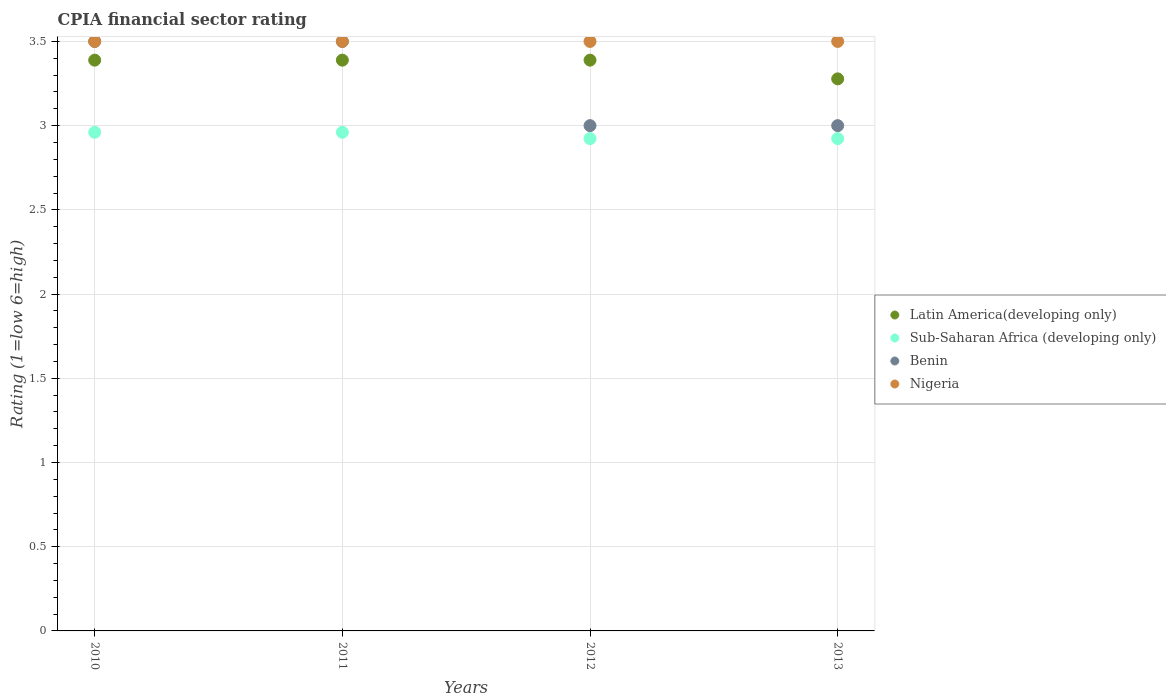Is the number of dotlines equal to the number of legend labels?
Provide a succinct answer. Yes. What is the CPIA rating in Sub-Saharan Africa (developing only) in 2013?
Provide a short and direct response. 2.92. Across all years, what is the maximum CPIA rating in Sub-Saharan Africa (developing only)?
Keep it short and to the point. 2.96. Across all years, what is the minimum CPIA rating in Latin America(developing only)?
Your answer should be very brief. 3.28. In which year was the CPIA rating in Sub-Saharan Africa (developing only) maximum?
Ensure brevity in your answer.  2010. What is the total CPIA rating in Nigeria in the graph?
Provide a short and direct response. 14. What is the difference between the CPIA rating in Latin America(developing only) in 2010 and that in 2013?
Your answer should be very brief. 0.11. What is the difference between the CPIA rating in Nigeria in 2010 and the CPIA rating in Latin America(developing only) in 2012?
Offer a very short reply. 0.11. What is the average CPIA rating in Benin per year?
Your answer should be very brief. 3.25. In the year 2012, what is the difference between the CPIA rating in Sub-Saharan Africa (developing only) and CPIA rating in Latin America(developing only)?
Make the answer very short. -0.47. In how many years, is the CPIA rating in Sub-Saharan Africa (developing only) greater than 1.9?
Keep it short and to the point. 4. What is the ratio of the CPIA rating in Benin in 2011 to that in 2013?
Your answer should be very brief. 1.17. What is the difference between the highest and the second highest CPIA rating in Sub-Saharan Africa (developing only)?
Offer a terse response. 0. What is the difference between the highest and the lowest CPIA rating in Sub-Saharan Africa (developing only)?
Keep it short and to the point. 0.04. In how many years, is the CPIA rating in Sub-Saharan Africa (developing only) greater than the average CPIA rating in Sub-Saharan Africa (developing only) taken over all years?
Ensure brevity in your answer.  2. Is it the case that in every year, the sum of the CPIA rating in Nigeria and CPIA rating in Sub-Saharan Africa (developing only)  is greater than the sum of CPIA rating in Latin America(developing only) and CPIA rating in Benin?
Your answer should be compact. No. Is the CPIA rating in Nigeria strictly greater than the CPIA rating in Latin America(developing only) over the years?
Provide a succinct answer. Yes. Is the CPIA rating in Nigeria strictly less than the CPIA rating in Benin over the years?
Keep it short and to the point. No. Does the graph contain any zero values?
Your answer should be compact. No. Where does the legend appear in the graph?
Your answer should be very brief. Center right. How many legend labels are there?
Your response must be concise. 4. How are the legend labels stacked?
Your answer should be very brief. Vertical. What is the title of the graph?
Ensure brevity in your answer.  CPIA financial sector rating. What is the label or title of the X-axis?
Your response must be concise. Years. What is the label or title of the Y-axis?
Offer a terse response. Rating (1=low 6=high). What is the Rating (1=low 6=high) in Latin America(developing only) in 2010?
Give a very brief answer. 3.39. What is the Rating (1=low 6=high) in Sub-Saharan Africa (developing only) in 2010?
Provide a succinct answer. 2.96. What is the Rating (1=low 6=high) of Nigeria in 2010?
Keep it short and to the point. 3.5. What is the Rating (1=low 6=high) of Latin America(developing only) in 2011?
Provide a succinct answer. 3.39. What is the Rating (1=low 6=high) of Sub-Saharan Africa (developing only) in 2011?
Make the answer very short. 2.96. What is the Rating (1=low 6=high) in Benin in 2011?
Provide a succinct answer. 3.5. What is the Rating (1=low 6=high) of Nigeria in 2011?
Provide a succinct answer. 3.5. What is the Rating (1=low 6=high) in Latin America(developing only) in 2012?
Your answer should be compact. 3.39. What is the Rating (1=low 6=high) in Sub-Saharan Africa (developing only) in 2012?
Your answer should be compact. 2.92. What is the Rating (1=low 6=high) of Latin America(developing only) in 2013?
Give a very brief answer. 3.28. What is the Rating (1=low 6=high) of Sub-Saharan Africa (developing only) in 2013?
Provide a short and direct response. 2.92. What is the Rating (1=low 6=high) of Nigeria in 2013?
Keep it short and to the point. 3.5. Across all years, what is the maximum Rating (1=low 6=high) in Latin America(developing only)?
Make the answer very short. 3.39. Across all years, what is the maximum Rating (1=low 6=high) of Sub-Saharan Africa (developing only)?
Your answer should be very brief. 2.96. Across all years, what is the maximum Rating (1=low 6=high) of Nigeria?
Keep it short and to the point. 3.5. Across all years, what is the minimum Rating (1=low 6=high) of Latin America(developing only)?
Offer a very short reply. 3.28. Across all years, what is the minimum Rating (1=low 6=high) in Sub-Saharan Africa (developing only)?
Provide a succinct answer. 2.92. Across all years, what is the minimum Rating (1=low 6=high) in Nigeria?
Your response must be concise. 3.5. What is the total Rating (1=low 6=high) of Latin America(developing only) in the graph?
Offer a terse response. 13.44. What is the total Rating (1=low 6=high) in Sub-Saharan Africa (developing only) in the graph?
Offer a terse response. 11.77. What is the total Rating (1=low 6=high) in Nigeria in the graph?
Offer a very short reply. 14. What is the difference between the Rating (1=low 6=high) in Benin in 2010 and that in 2011?
Your answer should be very brief. 0. What is the difference between the Rating (1=low 6=high) of Latin America(developing only) in 2010 and that in 2012?
Ensure brevity in your answer.  0. What is the difference between the Rating (1=low 6=high) of Sub-Saharan Africa (developing only) in 2010 and that in 2012?
Make the answer very short. 0.04. What is the difference between the Rating (1=low 6=high) in Benin in 2010 and that in 2012?
Your answer should be compact. 0.5. What is the difference between the Rating (1=low 6=high) in Sub-Saharan Africa (developing only) in 2010 and that in 2013?
Provide a short and direct response. 0.04. What is the difference between the Rating (1=low 6=high) in Benin in 2010 and that in 2013?
Offer a terse response. 0.5. What is the difference between the Rating (1=low 6=high) of Latin America(developing only) in 2011 and that in 2012?
Ensure brevity in your answer.  0. What is the difference between the Rating (1=low 6=high) in Sub-Saharan Africa (developing only) in 2011 and that in 2012?
Keep it short and to the point. 0.04. What is the difference between the Rating (1=low 6=high) in Nigeria in 2011 and that in 2012?
Keep it short and to the point. 0. What is the difference between the Rating (1=low 6=high) in Latin America(developing only) in 2011 and that in 2013?
Provide a short and direct response. 0.11. What is the difference between the Rating (1=low 6=high) in Sub-Saharan Africa (developing only) in 2011 and that in 2013?
Your answer should be compact. 0.04. What is the difference between the Rating (1=low 6=high) of Sub-Saharan Africa (developing only) in 2012 and that in 2013?
Ensure brevity in your answer.  0. What is the difference between the Rating (1=low 6=high) of Benin in 2012 and that in 2013?
Make the answer very short. 0. What is the difference between the Rating (1=low 6=high) in Nigeria in 2012 and that in 2013?
Offer a terse response. 0. What is the difference between the Rating (1=low 6=high) of Latin America(developing only) in 2010 and the Rating (1=low 6=high) of Sub-Saharan Africa (developing only) in 2011?
Your answer should be very brief. 0.43. What is the difference between the Rating (1=low 6=high) of Latin America(developing only) in 2010 and the Rating (1=low 6=high) of Benin in 2011?
Your answer should be very brief. -0.11. What is the difference between the Rating (1=low 6=high) of Latin America(developing only) in 2010 and the Rating (1=low 6=high) of Nigeria in 2011?
Make the answer very short. -0.11. What is the difference between the Rating (1=low 6=high) in Sub-Saharan Africa (developing only) in 2010 and the Rating (1=low 6=high) in Benin in 2011?
Offer a terse response. -0.54. What is the difference between the Rating (1=low 6=high) in Sub-Saharan Africa (developing only) in 2010 and the Rating (1=low 6=high) in Nigeria in 2011?
Offer a terse response. -0.54. What is the difference between the Rating (1=low 6=high) in Benin in 2010 and the Rating (1=low 6=high) in Nigeria in 2011?
Your response must be concise. 0. What is the difference between the Rating (1=low 6=high) of Latin America(developing only) in 2010 and the Rating (1=low 6=high) of Sub-Saharan Africa (developing only) in 2012?
Make the answer very short. 0.47. What is the difference between the Rating (1=low 6=high) of Latin America(developing only) in 2010 and the Rating (1=low 6=high) of Benin in 2012?
Ensure brevity in your answer.  0.39. What is the difference between the Rating (1=low 6=high) in Latin America(developing only) in 2010 and the Rating (1=low 6=high) in Nigeria in 2012?
Offer a terse response. -0.11. What is the difference between the Rating (1=low 6=high) of Sub-Saharan Africa (developing only) in 2010 and the Rating (1=low 6=high) of Benin in 2012?
Make the answer very short. -0.04. What is the difference between the Rating (1=low 6=high) in Sub-Saharan Africa (developing only) in 2010 and the Rating (1=low 6=high) in Nigeria in 2012?
Your response must be concise. -0.54. What is the difference between the Rating (1=low 6=high) of Latin America(developing only) in 2010 and the Rating (1=low 6=high) of Sub-Saharan Africa (developing only) in 2013?
Provide a short and direct response. 0.47. What is the difference between the Rating (1=low 6=high) in Latin America(developing only) in 2010 and the Rating (1=low 6=high) in Benin in 2013?
Offer a very short reply. 0.39. What is the difference between the Rating (1=low 6=high) of Latin America(developing only) in 2010 and the Rating (1=low 6=high) of Nigeria in 2013?
Provide a succinct answer. -0.11. What is the difference between the Rating (1=low 6=high) of Sub-Saharan Africa (developing only) in 2010 and the Rating (1=low 6=high) of Benin in 2013?
Give a very brief answer. -0.04. What is the difference between the Rating (1=low 6=high) in Sub-Saharan Africa (developing only) in 2010 and the Rating (1=low 6=high) in Nigeria in 2013?
Give a very brief answer. -0.54. What is the difference between the Rating (1=low 6=high) in Benin in 2010 and the Rating (1=low 6=high) in Nigeria in 2013?
Your response must be concise. 0. What is the difference between the Rating (1=low 6=high) in Latin America(developing only) in 2011 and the Rating (1=low 6=high) in Sub-Saharan Africa (developing only) in 2012?
Your response must be concise. 0.47. What is the difference between the Rating (1=low 6=high) in Latin America(developing only) in 2011 and the Rating (1=low 6=high) in Benin in 2012?
Give a very brief answer. 0.39. What is the difference between the Rating (1=low 6=high) of Latin America(developing only) in 2011 and the Rating (1=low 6=high) of Nigeria in 2012?
Provide a succinct answer. -0.11. What is the difference between the Rating (1=low 6=high) in Sub-Saharan Africa (developing only) in 2011 and the Rating (1=low 6=high) in Benin in 2012?
Give a very brief answer. -0.04. What is the difference between the Rating (1=low 6=high) in Sub-Saharan Africa (developing only) in 2011 and the Rating (1=low 6=high) in Nigeria in 2012?
Offer a very short reply. -0.54. What is the difference between the Rating (1=low 6=high) of Latin America(developing only) in 2011 and the Rating (1=low 6=high) of Sub-Saharan Africa (developing only) in 2013?
Offer a terse response. 0.47. What is the difference between the Rating (1=low 6=high) in Latin America(developing only) in 2011 and the Rating (1=low 6=high) in Benin in 2013?
Your answer should be very brief. 0.39. What is the difference between the Rating (1=low 6=high) of Latin America(developing only) in 2011 and the Rating (1=low 6=high) of Nigeria in 2013?
Provide a succinct answer. -0.11. What is the difference between the Rating (1=low 6=high) of Sub-Saharan Africa (developing only) in 2011 and the Rating (1=low 6=high) of Benin in 2013?
Offer a very short reply. -0.04. What is the difference between the Rating (1=low 6=high) of Sub-Saharan Africa (developing only) in 2011 and the Rating (1=low 6=high) of Nigeria in 2013?
Keep it short and to the point. -0.54. What is the difference between the Rating (1=low 6=high) in Benin in 2011 and the Rating (1=low 6=high) in Nigeria in 2013?
Offer a terse response. 0. What is the difference between the Rating (1=low 6=high) in Latin America(developing only) in 2012 and the Rating (1=low 6=high) in Sub-Saharan Africa (developing only) in 2013?
Keep it short and to the point. 0.47. What is the difference between the Rating (1=low 6=high) in Latin America(developing only) in 2012 and the Rating (1=low 6=high) in Benin in 2013?
Keep it short and to the point. 0.39. What is the difference between the Rating (1=low 6=high) in Latin America(developing only) in 2012 and the Rating (1=low 6=high) in Nigeria in 2013?
Offer a very short reply. -0.11. What is the difference between the Rating (1=low 6=high) of Sub-Saharan Africa (developing only) in 2012 and the Rating (1=low 6=high) of Benin in 2013?
Your answer should be very brief. -0.08. What is the difference between the Rating (1=low 6=high) of Sub-Saharan Africa (developing only) in 2012 and the Rating (1=low 6=high) of Nigeria in 2013?
Give a very brief answer. -0.58. What is the difference between the Rating (1=low 6=high) in Benin in 2012 and the Rating (1=low 6=high) in Nigeria in 2013?
Your response must be concise. -0.5. What is the average Rating (1=low 6=high) in Latin America(developing only) per year?
Your response must be concise. 3.36. What is the average Rating (1=low 6=high) of Sub-Saharan Africa (developing only) per year?
Provide a short and direct response. 2.94. What is the average Rating (1=low 6=high) in Benin per year?
Your response must be concise. 3.25. What is the average Rating (1=low 6=high) of Nigeria per year?
Provide a short and direct response. 3.5. In the year 2010, what is the difference between the Rating (1=low 6=high) in Latin America(developing only) and Rating (1=low 6=high) in Sub-Saharan Africa (developing only)?
Ensure brevity in your answer.  0.43. In the year 2010, what is the difference between the Rating (1=low 6=high) of Latin America(developing only) and Rating (1=low 6=high) of Benin?
Keep it short and to the point. -0.11. In the year 2010, what is the difference between the Rating (1=low 6=high) of Latin America(developing only) and Rating (1=low 6=high) of Nigeria?
Your response must be concise. -0.11. In the year 2010, what is the difference between the Rating (1=low 6=high) in Sub-Saharan Africa (developing only) and Rating (1=low 6=high) in Benin?
Offer a very short reply. -0.54. In the year 2010, what is the difference between the Rating (1=low 6=high) in Sub-Saharan Africa (developing only) and Rating (1=low 6=high) in Nigeria?
Provide a short and direct response. -0.54. In the year 2010, what is the difference between the Rating (1=low 6=high) in Benin and Rating (1=low 6=high) in Nigeria?
Keep it short and to the point. 0. In the year 2011, what is the difference between the Rating (1=low 6=high) in Latin America(developing only) and Rating (1=low 6=high) in Sub-Saharan Africa (developing only)?
Your response must be concise. 0.43. In the year 2011, what is the difference between the Rating (1=low 6=high) in Latin America(developing only) and Rating (1=low 6=high) in Benin?
Make the answer very short. -0.11. In the year 2011, what is the difference between the Rating (1=low 6=high) of Latin America(developing only) and Rating (1=low 6=high) of Nigeria?
Your answer should be compact. -0.11. In the year 2011, what is the difference between the Rating (1=low 6=high) in Sub-Saharan Africa (developing only) and Rating (1=low 6=high) in Benin?
Your response must be concise. -0.54. In the year 2011, what is the difference between the Rating (1=low 6=high) of Sub-Saharan Africa (developing only) and Rating (1=low 6=high) of Nigeria?
Your answer should be compact. -0.54. In the year 2012, what is the difference between the Rating (1=low 6=high) in Latin America(developing only) and Rating (1=low 6=high) in Sub-Saharan Africa (developing only)?
Your answer should be compact. 0.47. In the year 2012, what is the difference between the Rating (1=low 6=high) in Latin America(developing only) and Rating (1=low 6=high) in Benin?
Your response must be concise. 0.39. In the year 2012, what is the difference between the Rating (1=low 6=high) of Latin America(developing only) and Rating (1=low 6=high) of Nigeria?
Your response must be concise. -0.11. In the year 2012, what is the difference between the Rating (1=low 6=high) in Sub-Saharan Africa (developing only) and Rating (1=low 6=high) in Benin?
Give a very brief answer. -0.08. In the year 2012, what is the difference between the Rating (1=low 6=high) of Sub-Saharan Africa (developing only) and Rating (1=low 6=high) of Nigeria?
Ensure brevity in your answer.  -0.58. In the year 2013, what is the difference between the Rating (1=low 6=high) of Latin America(developing only) and Rating (1=low 6=high) of Sub-Saharan Africa (developing only)?
Provide a succinct answer. 0.35. In the year 2013, what is the difference between the Rating (1=low 6=high) in Latin America(developing only) and Rating (1=low 6=high) in Benin?
Your answer should be very brief. 0.28. In the year 2013, what is the difference between the Rating (1=low 6=high) of Latin America(developing only) and Rating (1=low 6=high) of Nigeria?
Ensure brevity in your answer.  -0.22. In the year 2013, what is the difference between the Rating (1=low 6=high) in Sub-Saharan Africa (developing only) and Rating (1=low 6=high) in Benin?
Offer a terse response. -0.08. In the year 2013, what is the difference between the Rating (1=low 6=high) of Sub-Saharan Africa (developing only) and Rating (1=low 6=high) of Nigeria?
Offer a very short reply. -0.58. What is the ratio of the Rating (1=low 6=high) of Sub-Saharan Africa (developing only) in 2010 to that in 2011?
Keep it short and to the point. 1. What is the ratio of the Rating (1=low 6=high) in Nigeria in 2010 to that in 2011?
Your response must be concise. 1. What is the ratio of the Rating (1=low 6=high) of Sub-Saharan Africa (developing only) in 2010 to that in 2012?
Offer a very short reply. 1.01. What is the ratio of the Rating (1=low 6=high) in Benin in 2010 to that in 2012?
Provide a short and direct response. 1.17. What is the ratio of the Rating (1=low 6=high) of Latin America(developing only) in 2010 to that in 2013?
Your response must be concise. 1.03. What is the ratio of the Rating (1=low 6=high) of Sub-Saharan Africa (developing only) in 2010 to that in 2013?
Provide a succinct answer. 1.01. What is the ratio of the Rating (1=low 6=high) of Benin in 2010 to that in 2013?
Your answer should be very brief. 1.17. What is the ratio of the Rating (1=low 6=high) of Latin America(developing only) in 2011 to that in 2012?
Your answer should be very brief. 1. What is the ratio of the Rating (1=low 6=high) in Sub-Saharan Africa (developing only) in 2011 to that in 2012?
Your answer should be compact. 1.01. What is the ratio of the Rating (1=low 6=high) in Latin America(developing only) in 2011 to that in 2013?
Your answer should be very brief. 1.03. What is the ratio of the Rating (1=low 6=high) of Sub-Saharan Africa (developing only) in 2011 to that in 2013?
Make the answer very short. 1.01. What is the ratio of the Rating (1=low 6=high) of Benin in 2011 to that in 2013?
Keep it short and to the point. 1.17. What is the ratio of the Rating (1=low 6=high) of Latin America(developing only) in 2012 to that in 2013?
Provide a succinct answer. 1.03. What is the ratio of the Rating (1=low 6=high) of Benin in 2012 to that in 2013?
Your response must be concise. 1. What is the ratio of the Rating (1=low 6=high) of Nigeria in 2012 to that in 2013?
Ensure brevity in your answer.  1. What is the difference between the highest and the second highest Rating (1=low 6=high) of Nigeria?
Offer a very short reply. 0. What is the difference between the highest and the lowest Rating (1=low 6=high) of Latin America(developing only)?
Keep it short and to the point. 0.11. What is the difference between the highest and the lowest Rating (1=low 6=high) in Sub-Saharan Africa (developing only)?
Offer a terse response. 0.04. What is the difference between the highest and the lowest Rating (1=low 6=high) in Benin?
Offer a terse response. 0.5. What is the difference between the highest and the lowest Rating (1=low 6=high) of Nigeria?
Provide a short and direct response. 0. 